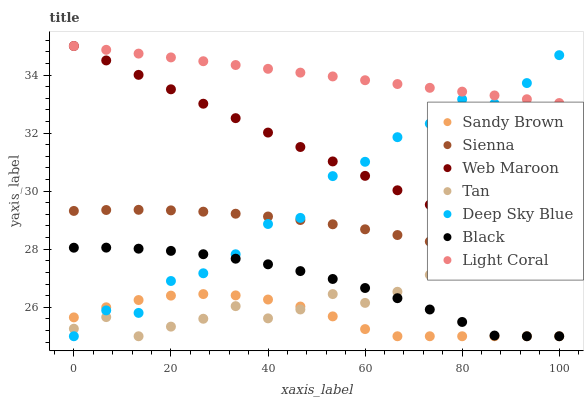Does Sandy Brown have the minimum area under the curve?
Answer yes or no. Yes. Does Light Coral have the maximum area under the curve?
Answer yes or no. Yes. Does Web Maroon have the minimum area under the curve?
Answer yes or no. No. Does Web Maroon have the maximum area under the curve?
Answer yes or no. No. Is Web Maroon the smoothest?
Answer yes or no. Yes. Is Deep Sky Blue the roughest?
Answer yes or no. Yes. Is Sienna the smoothest?
Answer yes or no. No. Is Sienna the roughest?
Answer yes or no. No. Does Black have the lowest value?
Answer yes or no. Yes. Does Web Maroon have the lowest value?
Answer yes or no. No. Does Web Maroon have the highest value?
Answer yes or no. Yes. Does Sienna have the highest value?
Answer yes or no. No. Is Sienna less than Light Coral?
Answer yes or no. Yes. Is Web Maroon greater than Sandy Brown?
Answer yes or no. Yes. Does Deep Sky Blue intersect Web Maroon?
Answer yes or no. Yes. Is Deep Sky Blue less than Web Maroon?
Answer yes or no. No. Is Deep Sky Blue greater than Web Maroon?
Answer yes or no. No. Does Sienna intersect Light Coral?
Answer yes or no. No. 